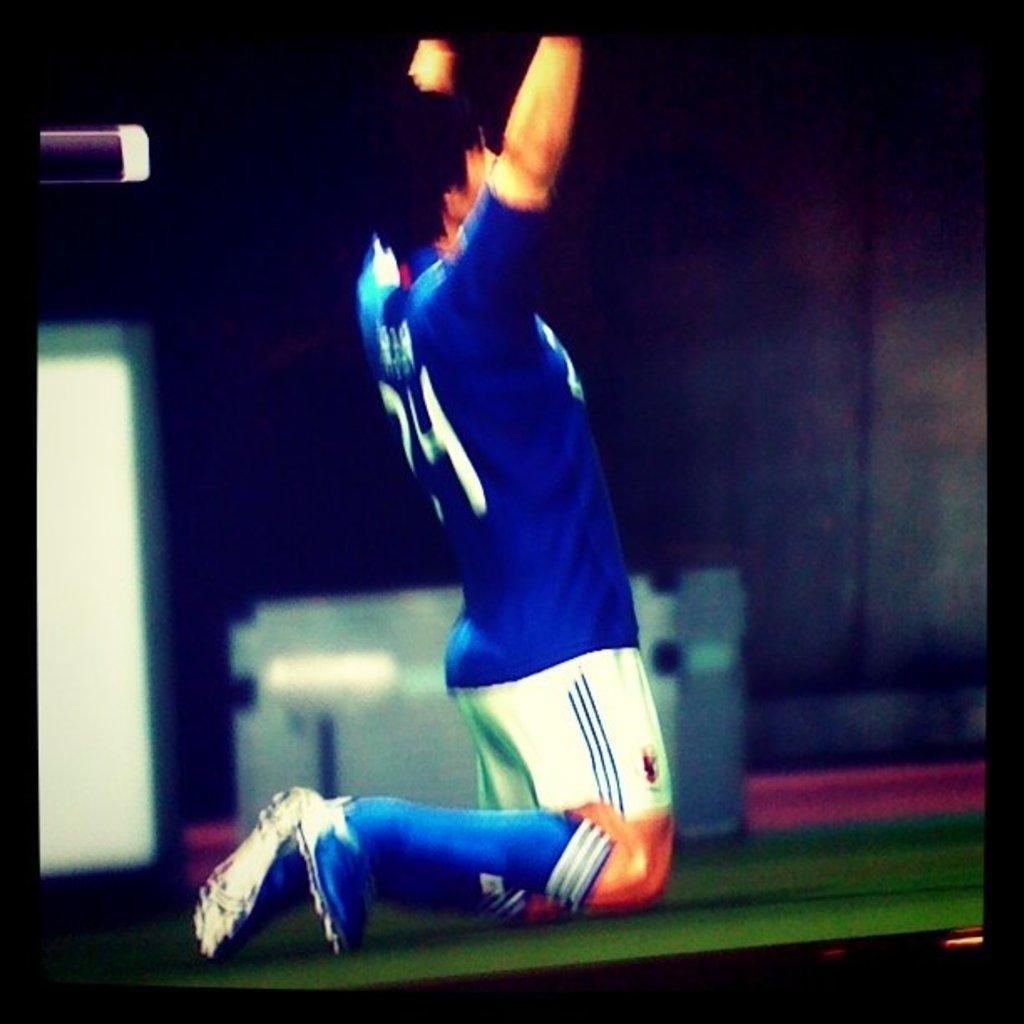Could you give a brief overview of what you see in this image? In this image we can see a person. In the background it is blurry and there are things. 